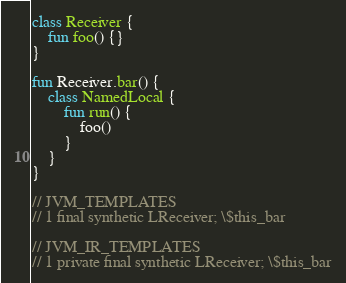<code> <loc_0><loc_0><loc_500><loc_500><_Kotlin_>class Receiver {
    fun foo() {}
}

fun Receiver.bar() {
    class NamedLocal {
        fun run() {
            foo()
        }
    }
}

// JVM_TEMPLATES
// 1 final synthetic LReceiver; \$this_bar

// JVM_IR_TEMPLATES
// 1 private final synthetic LReceiver; \$this_bar</code> 